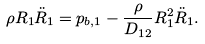<formula> <loc_0><loc_0><loc_500><loc_500>\rho R _ { 1 } \ddot { R } _ { 1 } = p _ { b , 1 } - \frac { \rho } { D _ { 1 2 } } R _ { 1 } ^ { 2 } \ddot { R } _ { 1 } .</formula> 